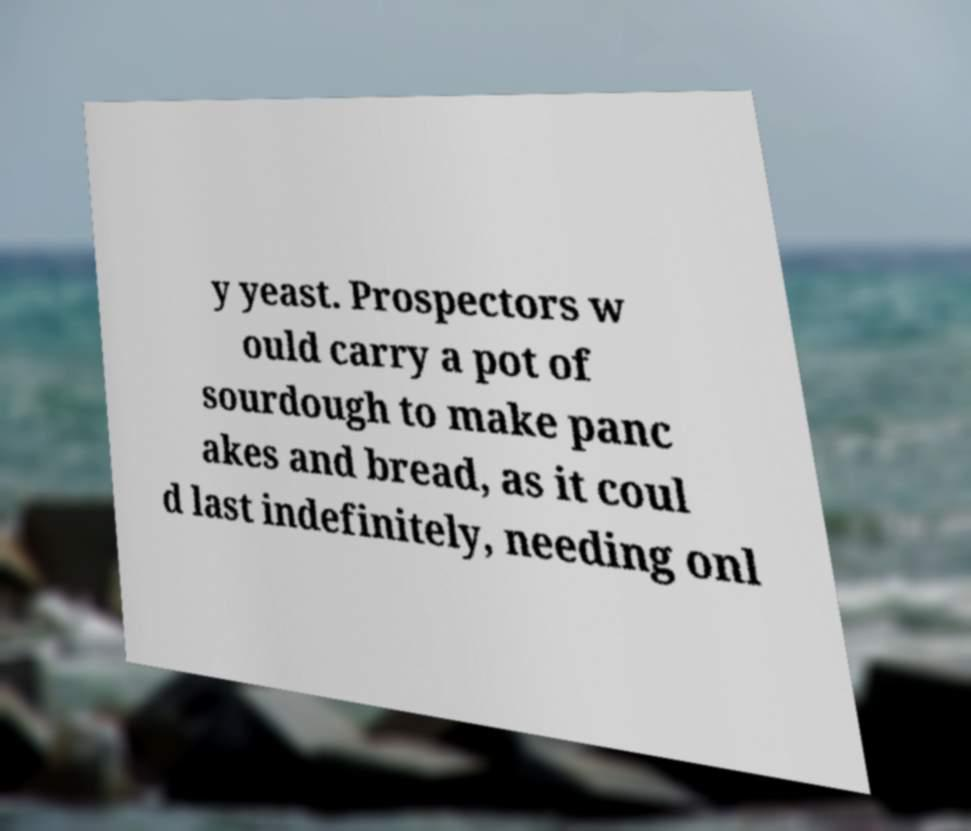For documentation purposes, I need the text within this image transcribed. Could you provide that? y yeast. Prospectors w ould carry a pot of sourdough to make panc akes and bread, as it coul d last indefinitely, needing onl 